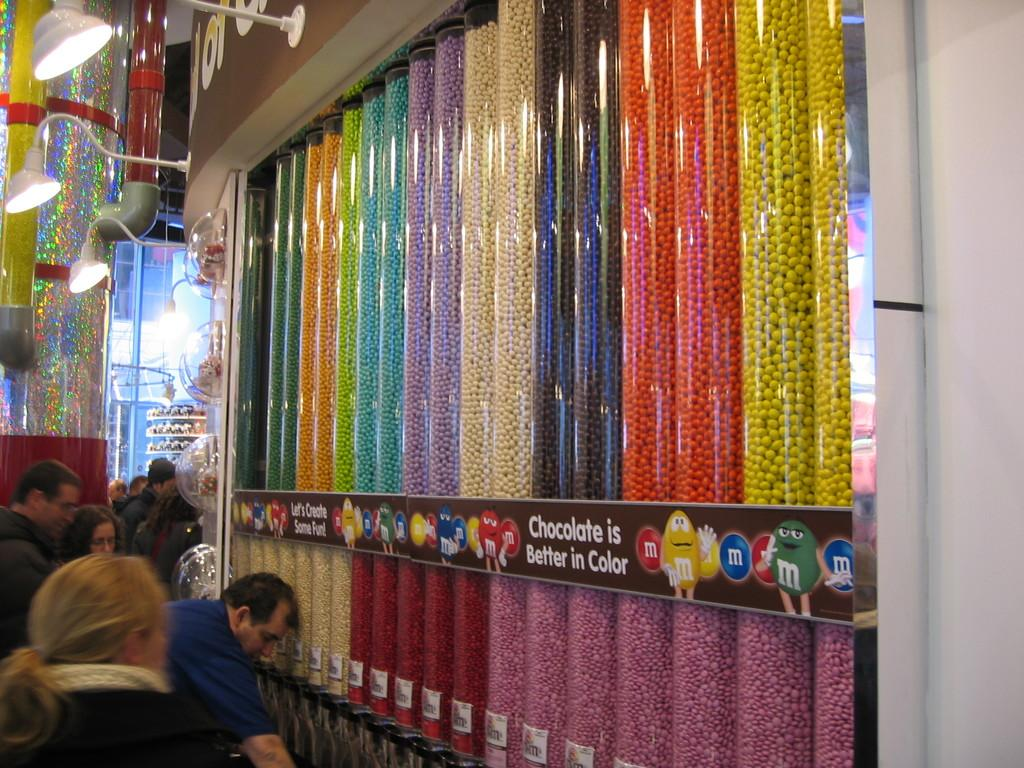Provide a one-sentence caption for the provided image. Series of dispensers containing M&M's of different colors. 